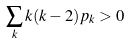<formula> <loc_0><loc_0><loc_500><loc_500>\sum _ { k } k ( k - 2 ) p _ { k } > 0</formula> 